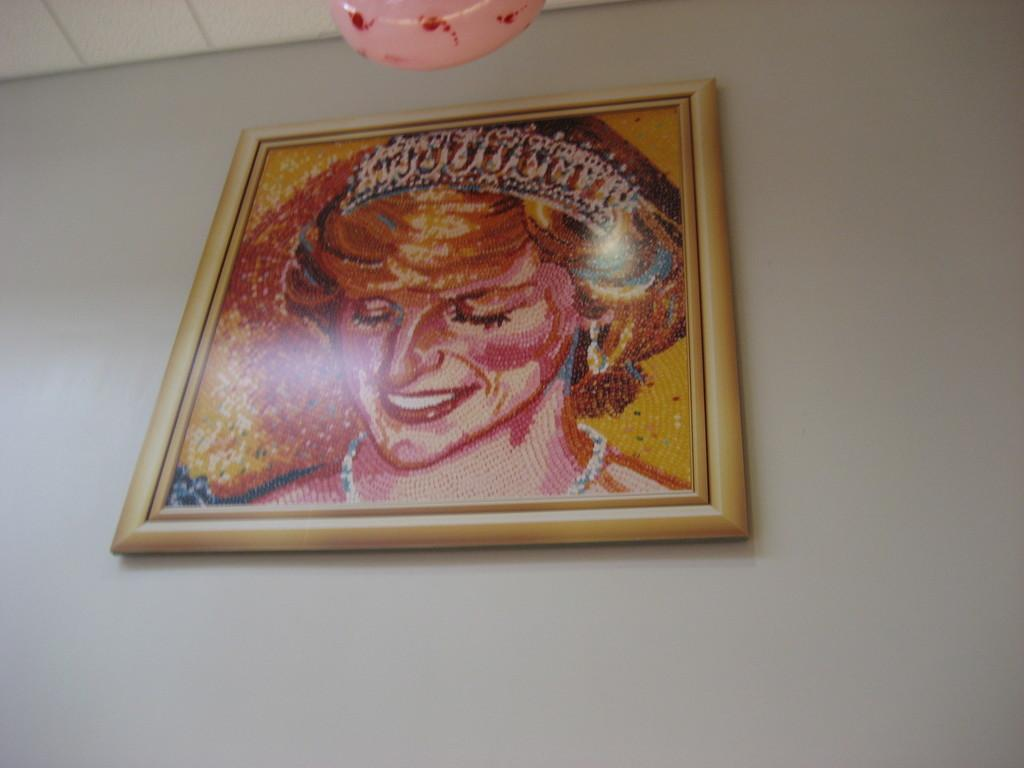What object is visible in the image that might hold a picture or artwork? There is a photo frame in the image. Where is the photo frame located in the image? The photo frame is on a wall. What type of artwork does the photo frame appear to hold? The photo frame appears to be a painting. How many nails are used to hang the painting in the image? There is no information about nails or the method of hanging the painting in the image. 